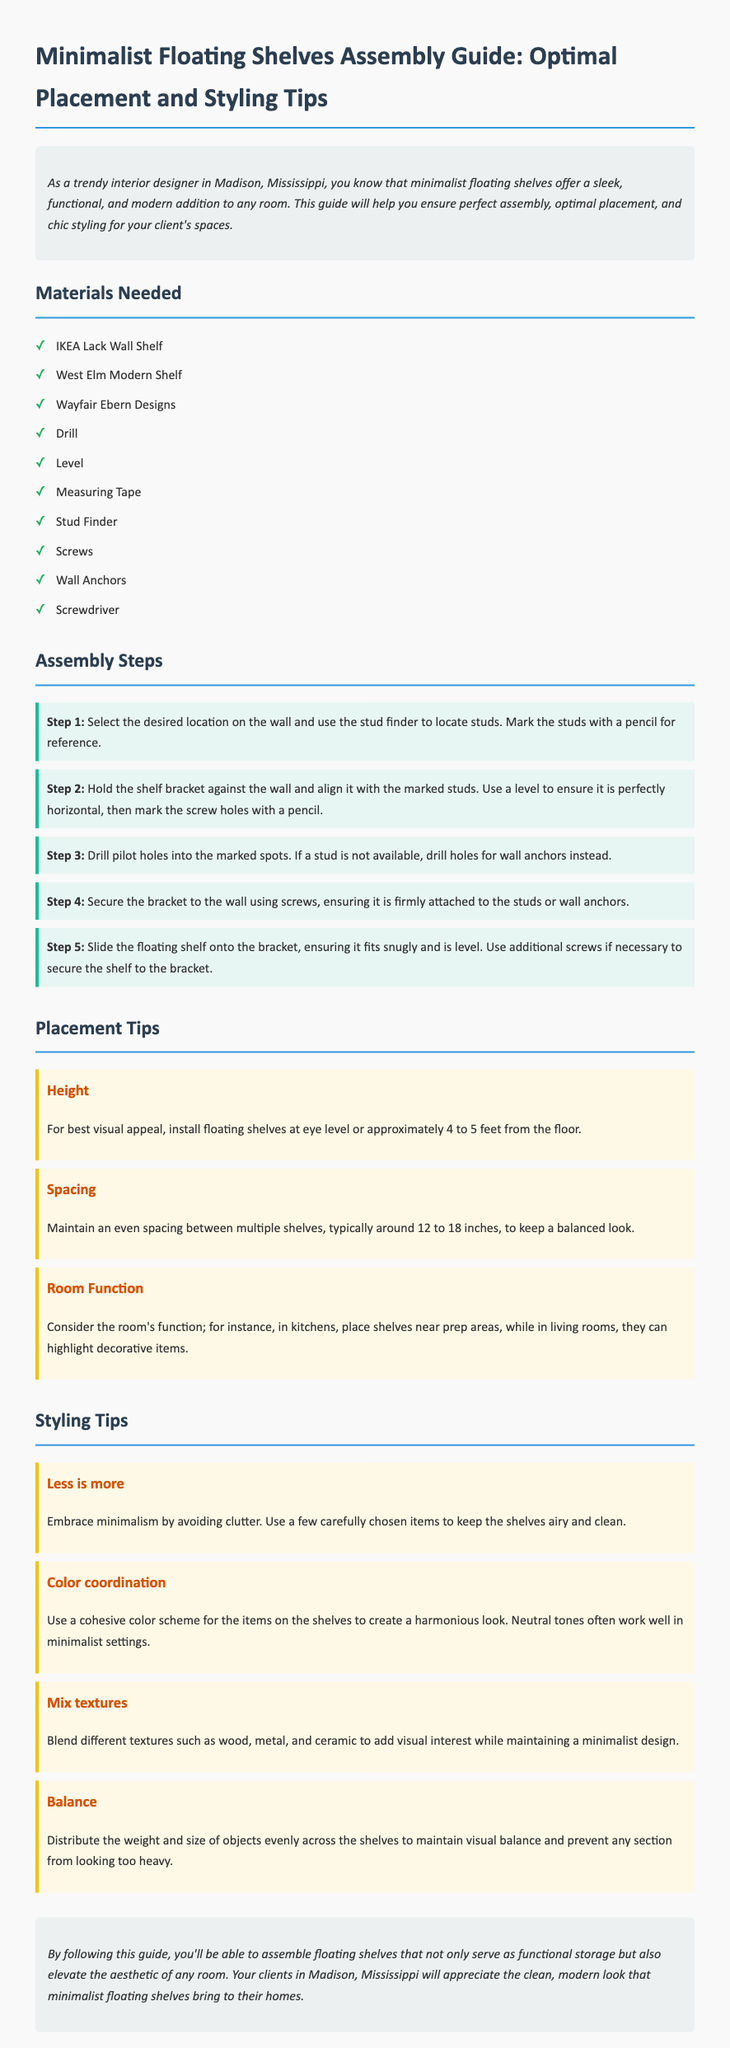What is the title of the document? The title is stated in the header of the document, which is "Minimalist Floating Shelves Assembly Guide: Optimal Placement and Styling Tips."
Answer: Minimalist Floating Shelves Assembly Guide: Optimal Placement and Styling Tips What is the first material listed? The materials section lists various items needed for assembly, and the first item is 'IKEA Lack Wall Shelf.'
Answer: IKEA Lack Wall Shelf How many assembly steps are there? The assembly section consists of a series of steps, and there are a total of five steps presented.
Answer: 5 What is the suggested height for installing floating shelves? The placement tips section provides a specific height recommendation for visual appeal, which is "approximately 4 to 5 feet from the floor."
Answer: 4 to 5 feet What is one styling tip mentioned? The styling tips section presents various recommendations, one of which is "Embrace minimalism by avoiding clutter."
Answer: Embrace minimalism by avoiding clutter Which brand is mentioned as a source for modern shelves? The materials needed list includes various brands, and one of them is 'West Elm Modern Shelf.'
Answer: West Elm Modern Shelf What color scheme is recommended for items on the shelves? The styling tips suggest using a cohesive color scheme, stating that "neutral tones often work well in minimalist settings."
Answer: Neutral tones Why is it important to balance objects on the shelves? The styling tips emphasize the importance of balance by stating it helps "maintain visual balance and prevent any section from looking too heavy."
Answer: Maintain visual balance What is a recommended spacing between multiple shelves? The placement tips section mentions an ideal spacing of "around 12 to 18 inches" between shelves for a balanced look.
Answer: 12 to 18 inches 